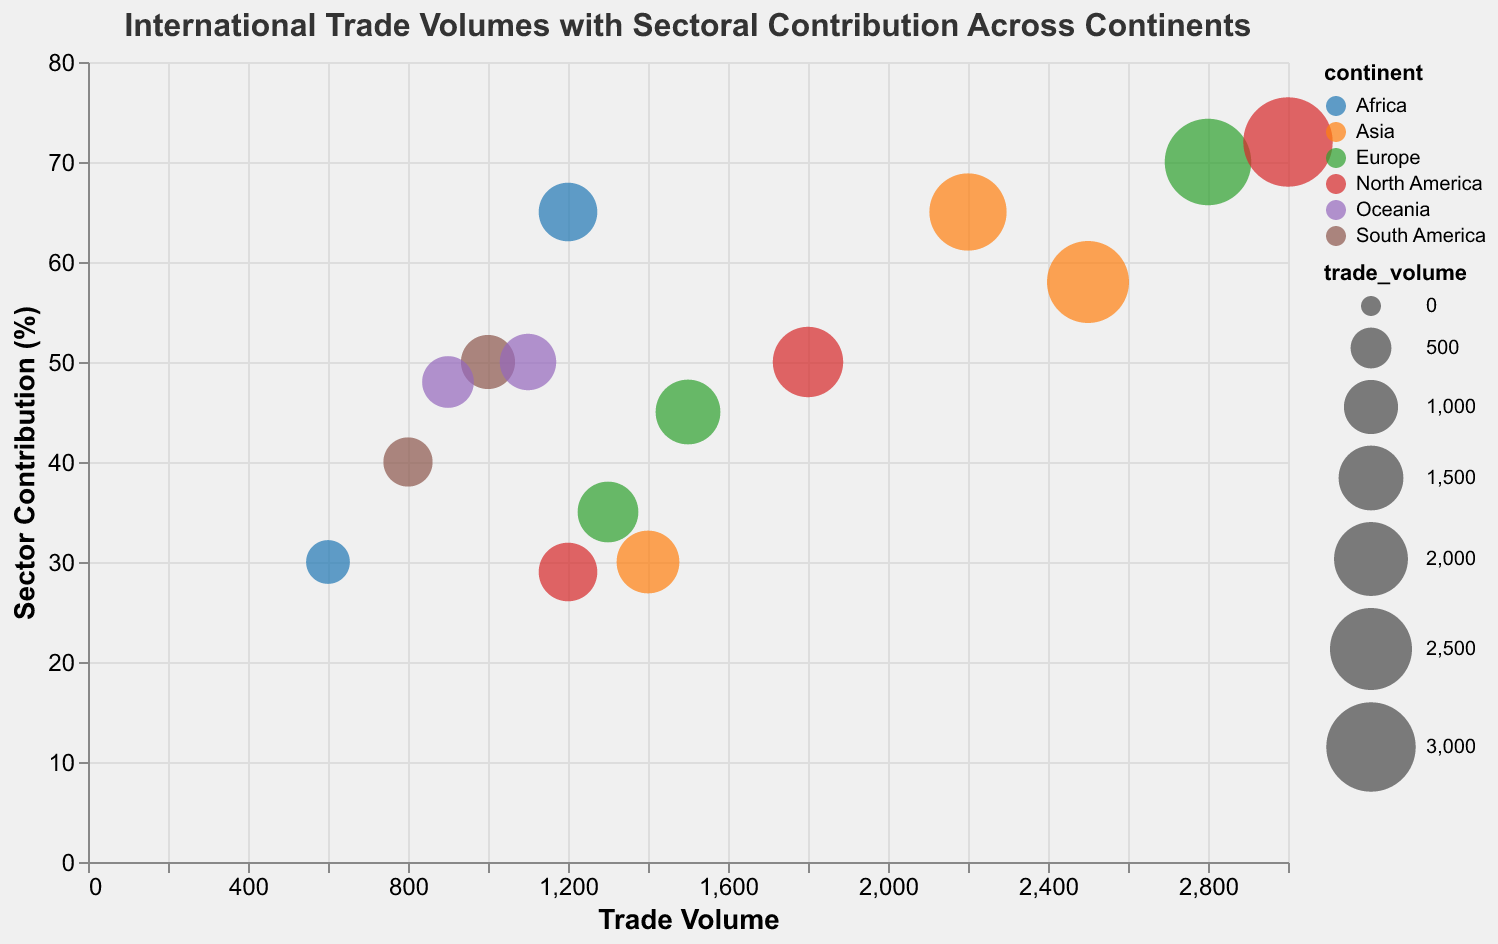How is the trade volume represented in the bubbles? The size of each bubble represents the trade volume. Larger bubbles indicate higher trade volumes, while smaller bubbles indicate lower trade volumes.
Answer: Bubble size Which continent has the highest trade volume in Technology? We can see by looking at the largest bubble in the Technology sector. The United States in North America has the highest trade volume in Technology, represented by the largest bubble in that sector.
Answer: North America What is the sector contribution for Agriculture in Nigeria? Locate the bubble for Nigeria in the Agriculture sector. The y-axis represents sector contribution percentage, and the bubble for Nigeria is aligned with the 30% mark.
Answer: 30% Which sector has the highest trade volume in the figure? To find the highest trade volume, locate the largest bubble. The United States' Technology sector has the highest trade volume at 3000.
Answer: Technology Compare the trade volumes of Agriculture between Mexico and France. Which one is higher? Look at the trade volumes along the x-axis for Agriculture bubbles. France has a trade volume of 1300, which is higher than Mexico's 1200.
Answer: France Which country has the highest sector contribution in the Mining sector? Observe the y-axis for the highest bubble in the Mining sector. South Africa appears at approximately 65%, which is the highest sector contribution in the Mining sector.
Answer: South Africa What is the average sector contribution of countries in Europe? Locate the bubbles for countries in Europe. Calculating average: (70% for Germany + 45% for Switzerland + 35% for France)/3 = (150/3) = 50%.
Answer: 50% Between Canada's Oil and Gas sector and Brazil's Mining sector, which has a higher trade volume? Look at the trade volume on the x-axis for Canada's Oil and Gas and Brazil's Mining sectors. Canada has a trade volume of 1800, while Brazil has 1000. Therefore, Canada's trade volume is higher.
Answer: Canada Which continent has the most varied sector contributions across countries? Analyze the sector contributions (y-axis) for each continent. North America has a range from 29% to 72%, showing the most variation.
Answer: North America In which continent and sector combination is trade volume relatively moderate (not the highest or lowest)? Identify moderate-sized bubbles. For example, Textiles in Asia demonstrates a moderate trade volume with a bubble size for India at 1400.
Answer: Asia, Textiles 